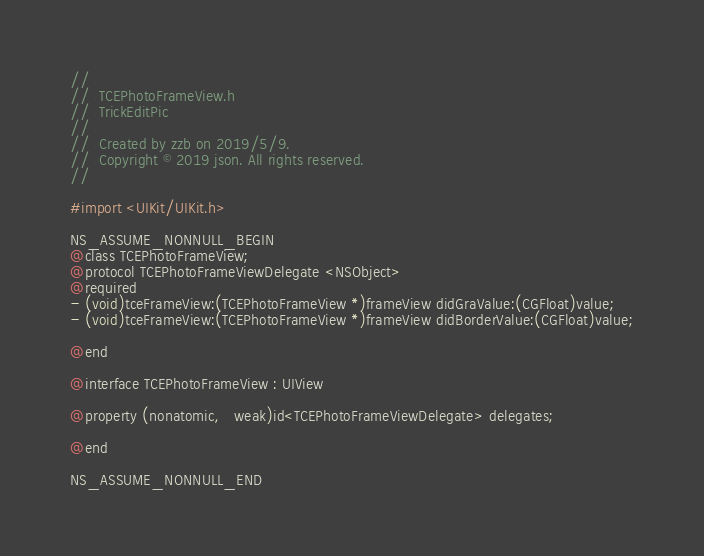Convert code to text. <code><loc_0><loc_0><loc_500><loc_500><_C_>//
//  TCEPhotoFrameView.h
//  TrickEditPic
//
//  Created by zzb on 2019/5/9.
//  Copyright © 2019 json. All rights reserved.
//

#import <UIKit/UIKit.h>

NS_ASSUME_NONNULL_BEGIN
@class TCEPhotoFrameView;
@protocol TCEPhotoFrameViewDelegate <NSObject>
@required
- (void)tceFrameView:(TCEPhotoFrameView *)frameView didGraValue:(CGFloat)value;
- (void)tceFrameView:(TCEPhotoFrameView *)frameView didBorderValue:(CGFloat)value;

@end

@interface TCEPhotoFrameView : UIView

@property (nonatomic,   weak)id<TCEPhotoFrameViewDelegate> delegates;

@end

NS_ASSUME_NONNULL_END
</code> 